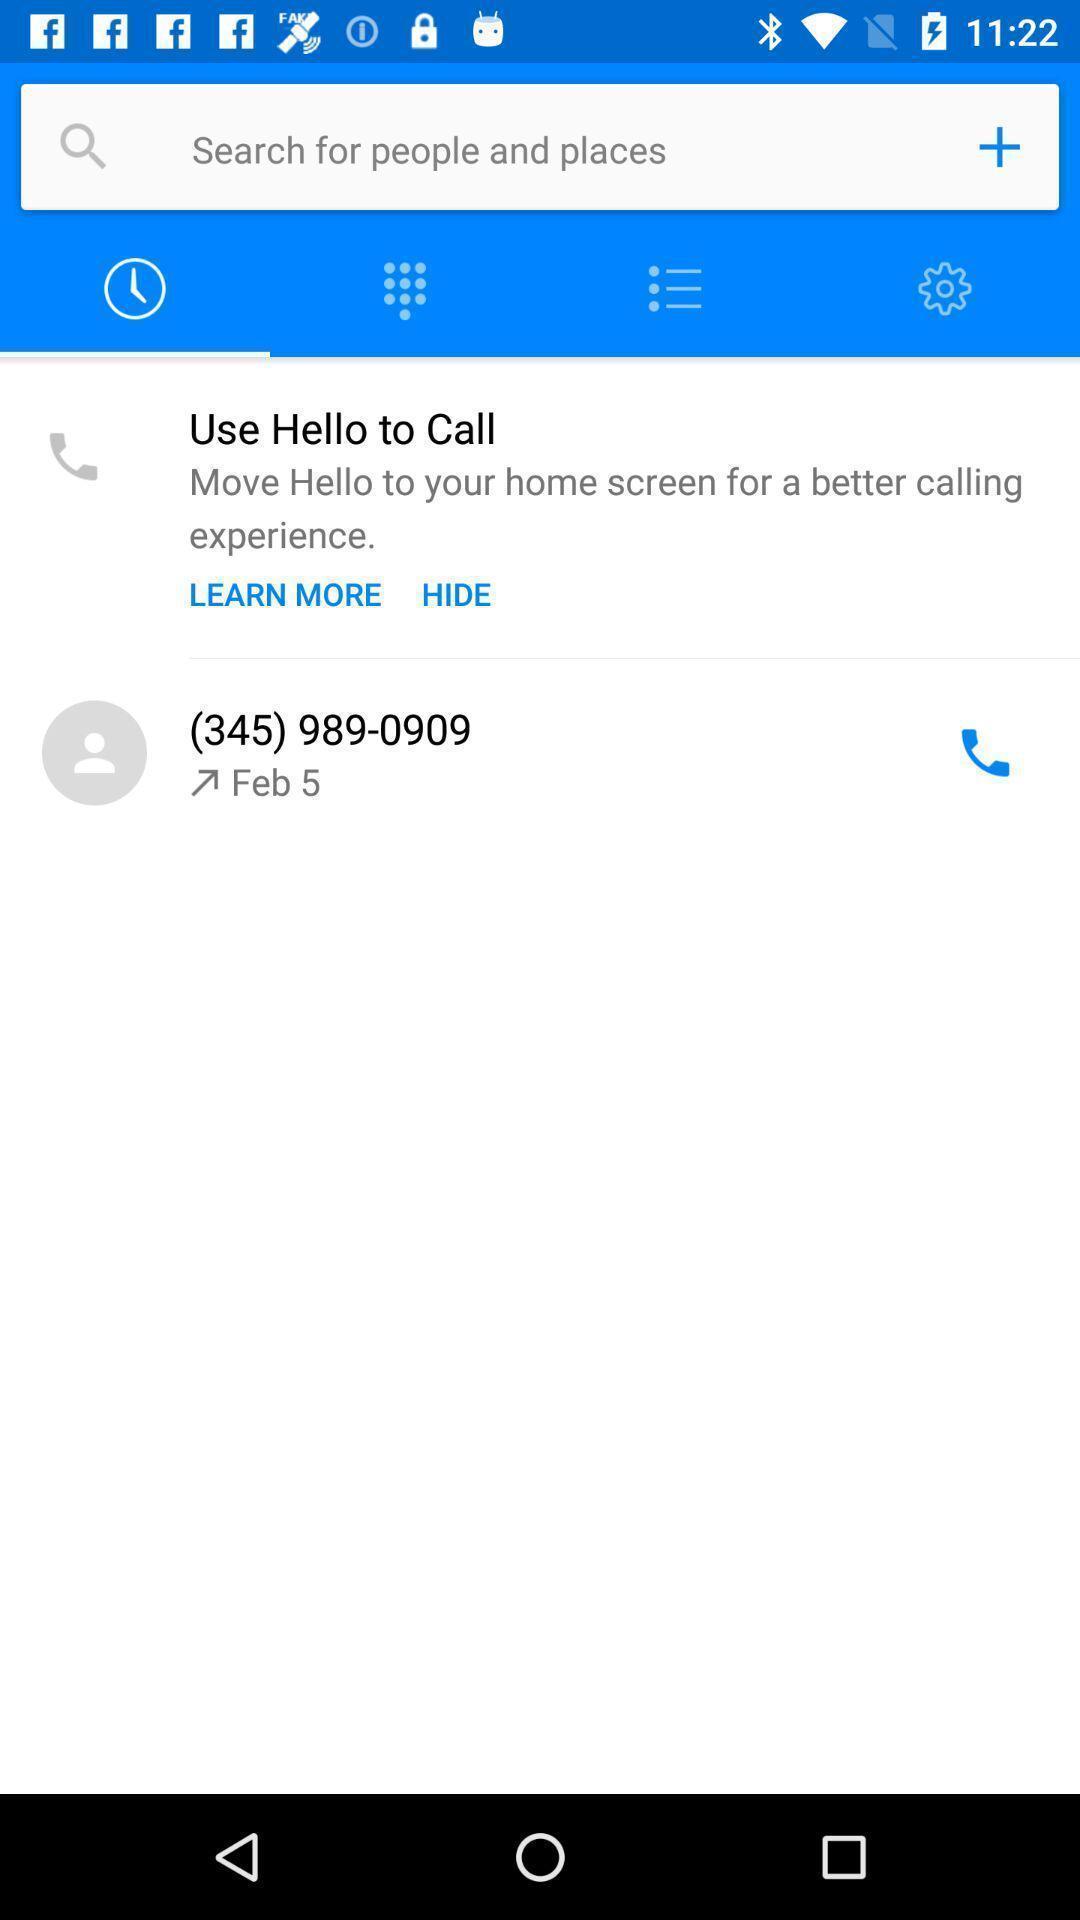Give me a summary of this screen capture. Screen displaying the call history page. 